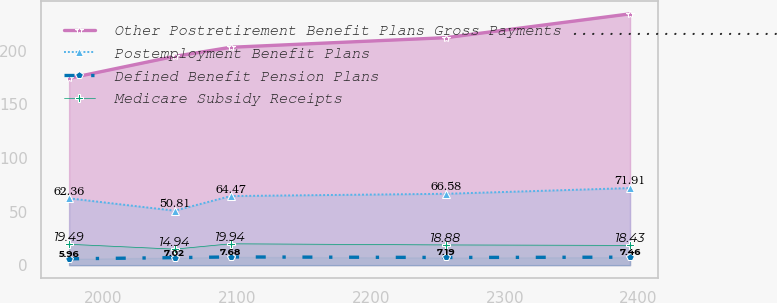Convert chart to OTSL. <chart><loc_0><loc_0><loc_500><loc_500><line_chart><ecel><fcel>Other Postretirement Benefit Plans Gross Payments .........................................................................................................................................................................................<fcel>Postemployment Benefit Plans<fcel>Defined Benefit Pension Plans<fcel>Medicare Subsidy Receipts<nl><fcel>1974.36<fcel>174.26<fcel>62.36<fcel>5.96<fcel>19.49<nl><fcel>2053.24<fcel>194.73<fcel>50.81<fcel>7.02<fcel>14.94<nl><fcel>2095.17<fcel>203.19<fcel>64.47<fcel>7.68<fcel>19.94<nl><fcel>2256.03<fcel>212.16<fcel>66.58<fcel>7.19<fcel>18.88<nl><fcel>2393.62<fcel>234.37<fcel>71.91<fcel>7.46<fcel>18.43<nl></chart> 